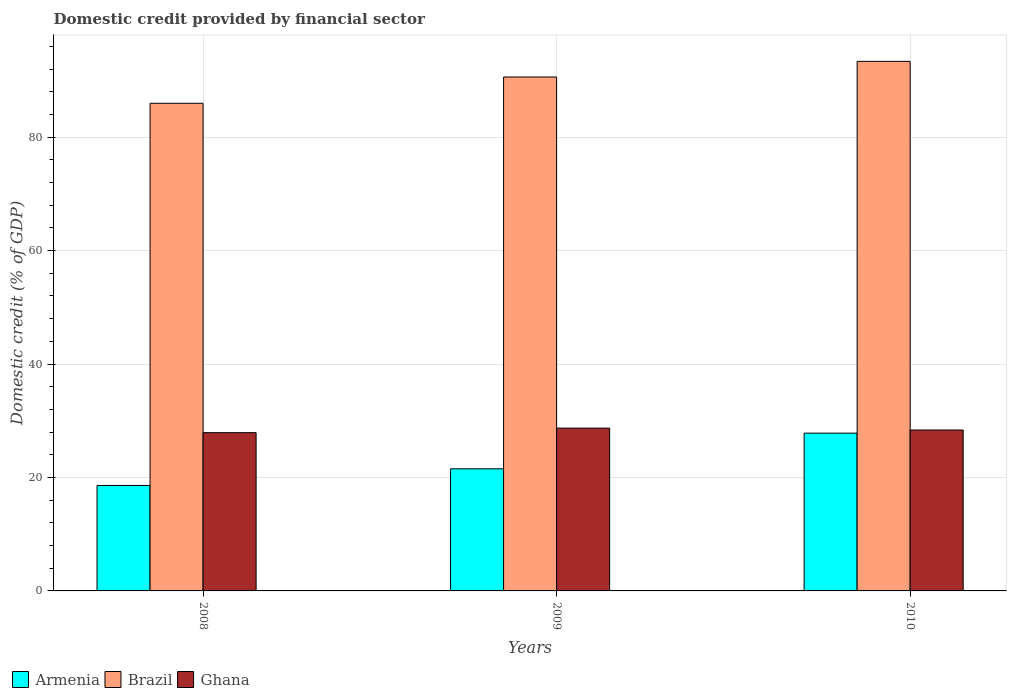How many groups of bars are there?
Provide a succinct answer. 3. Are the number of bars per tick equal to the number of legend labels?
Ensure brevity in your answer.  Yes. Are the number of bars on each tick of the X-axis equal?
Your answer should be compact. Yes. How many bars are there on the 2nd tick from the right?
Offer a very short reply. 3. What is the label of the 2nd group of bars from the left?
Give a very brief answer. 2009. In how many cases, is the number of bars for a given year not equal to the number of legend labels?
Offer a terse response. 0. What is the domestic credit in Ghana in 2010?
Your answer should be very brief. 28.37. Across all years, what is the maximum domestic credit in Armenia?
Provide a short and direct response. 27.82. Across all years, what is the minimum domestic credit in Ghana?
Provide a short and direct response. 27.9. In which year was the domestic credit in Ghana minimum?
Offer a terse response. 2008. What is the total domestic credit in Brazil in the graph?
Your response must be concise. 269.94. What is the difference between the domestic credit in Armenia in 2008 and that in 2009?
Make the answer very short. -2.94. What is the difference between the domestic credit in Brazil in 2008 and the domestic credit in Ghana in 2010?
Keep it short and to the point. 57.6. What is the average domestic credit in Armenia per year?
Provide a succinct answer. 22.65. In the year 2010, what is the difference between the domestic credit in Brazil and domestic credit in Armenia?
Make the answer very short. 65.55. In how many years, is the domestic credit in Brazil greater than 56 %?
Give a very brief answer. 3. What is the ratio of the domestic credit in Ghana in 2008 to that in 2010?
Give a very brief answer. 0.98. Is the domestic credit in Armenia in 2008 less than that in 2010?
Your answer should be very brief. Yes. Is the difference between the domestic credit in Brazil in 2009 and 2010 greater than the difference between the domestic credit in Armenia in 2009 and 2010?
Offer a very short reply. Yes. What is the difference between the highest and the second highest domestic credit in Armenia?
Offer a very short reply. 6.29. What is the difference between the highest and the lowest domestic credit in Brazil?
Ensure brevity in your answer.  7.39. Is it the case that in every year, the sum of the domestic credit in Ghana and domestic credit in Brazil is greater than the domestic credit in Armenia?
Make the answer very short. Yes. How many bars are there?
Provide a short and direct response. 9. How many years are there in the graph?
Offer a very short reply. 3. Are the values on the major ticks of Y-axis written in scientific E-notation?
Your answer should be compact. No. Does the graph contain any zero values?
Give a very brief answer. No. Does the graph contain grids?
Provide a succinct answer. Yes. How many legend labels are there?
Give a very brief answer. 3. What is the title of the graph?
Provide a succinct answer. Domestic credit provided by financial sector. Does "Grenada" appear as one of the legend labels in the graph?
Offer a terse response. No. What is the label or title of the Y-axis?
Make the answer very short. Domestic credit (% of GDP). What is the Domestic credit (% of GDP) of Armenia in 2008?
Your answer should be compact. 18.59. What is the Domestic credit (% of GDP) in Brazil in 2008?
Make the answer very short. 85.97. What is the Domestic credit (% of GDP) in Ghana in 2008?
Ensure brevity in your answer.  27.9. What is the Domestic credit (% of GDP) in Armenia in 2009?
Your answer should be very brief. 21.53. What is the Domestic credit (% of GDP) in Brazil in 2009?
Keep it short and to the point. 90.61. What is the Domestic credit (% of GDP) of Ghana in 2009?
Your answer should be very brief. 28.7. What is the Domestic credit (% of GDP) in Armenia in 2010?
Keep it short and to the point. 27.82. What is the Domestic credit (% of GDP) of Brazil in 2010?
Keep it short and to the point. 93.36. What is the Domestic credit (% of GDP) in Ghana in 2010?
Offer a terse response. 28.37. Across all years, what is the maximum Domestic credit (% of GDP) of Armenia?
Keep it short and to the point. 27.82. Across all years, what is the maximum Domestic credit (% of GDP) in Brazil?
Offer a very short reply. 93.36. Across all years, what is the maximum Domestic credit (% of GDP) of Ghana?
Offer a very short reply. 28.7. Across all years, what is the minimum Domestic credit (% of GDP) in Armenia?
Your answer should be very brief. 18.59. Across all years, what is the minimum Domestic credit (% of GDP) of Brazil?
Offer a very short reply. 85.97. Across all years, what is the minimum Domestic credit (% of GDP) of Ghana?
Ensure brevity in your answer.  27.9. What is the total Domestic credit (% of GDP) in Armenia in the graph?
Your response must be concise. 67.94. What is the total Domestic credit (% of GDP) in Brazil in the graph?
Ensure brevity in your answer.  269.94. What is the total Domestic credit (% of GDP) in Ghana in the graph?
Ensure brevity in your answer.  84.97. What is the difference between the Domestic credit (% of GDP) in Armenia in 2008 and that in 2009?
Give a very brief answer. -2.94. What is the difference between the Domestic credit (% of GDP) in Brazil in 2008 and that in 2009?
Your answer should be very brief. -4.64. What is the difference between the Domestic credit (% of GDP) in Ghana in 2008 and that in 2009?
Ensure brevity in your answer.  -0.8. What is the difference between the Domestic credit (% of GDP) of Armenia in 2008 and that in 2010?
Offer a very short reply. -9.22. What is the difference between the Domestic credit (% of GDP) of Brazil in 2008 and that in 2010?
Provide a short and direct response. -7.39. What is the difference between the Domestic credit (% of GDP) of Ghana in 2008 and that in 2010?
Offer a terse response. -0.47. What is the difference between the Domestic credit (% of GDP) of Armenia in 2009 and that in 2010?
Offer a very short reply. -6.29. What is the difference between the Domestic credit (% of GDP) of Brazil in 2009 and that in 2010?
Provide a short and direct response. -2.76. What is the difference between the Domestic credit (% of GDP) of Ghana in 2009 and that in 2010?
Give a very brief answer. 0.33. What is the difference between the Domestic credit (% of GDP) in Armenia in 2008 and the Domestic credit (% of GDP) in Brazil in 2009?
Your response must be concise. -72.01. What is the difference between the Domestic credit (% of GDP) of Armenia in 2008 and the Domestic credit (% of GDP) of Ghana in 2009?
Keep it short and to the point. -10.11. What is the difference between the Domestic credit (% of GDP) in Brazil in 2008 and the Domestic credit (% of GDP) in Ghana in 2009?
Ensure brevity in your answer.  57.27. What is the difference between the Domestic credit (% of GDP) in Armenia in 2008 and the Domestic credit (% of GDP) in Brazil in 2010?
Provide a succinct answer. -74.77. What is the difference between the Domestic credit (% of GDP) in Armenia in 2008 and the Domestic credit (% of GDP) in Ghana in 2010?
Offer a very short reply. -9.78. What is the difference between the Domestic credit (% of GDP) of Brazil in 2008 and the Domestic credit (% of GDP) of Ghana in 2010?
Provide a short and direct response. 57.6. What is the difference between the Domestic credit (% of GDP) in Armenia in 2009 and the Domestic credit (% of GDP) in Brazil in 2010?
Your response must be concise. -71.84. What is the difference between the Domestic credit (% of GDP) in Armenia in 2009 and the Domestic credit (% of GDP) in Ghana in 2010?
Keep it short and to the point. -6.84. What is the difference between the Domestic credit (% of GDP) of Brazil in 2009 and the Domestic credit (% of GDP) of Ghana in 2010?
Give a very brief answer. 62.24. What is the average Domestic credit (% of GDP) of Armenia per year?
Ensure brevity in your answer.  22.65. What is the average Domestic credit (% of GDP) in Brazil per year?
Provide a succinct answer. 89.98. What is the average Domestic credit (% of GDP) of Ghana per year?
Make the answer very short. 28.32. In the year 2008, what is the difference between the Domestic credit (% of GDP) of Armenia and Domestic credit (% of GDP) of Brazil?
Keep it short and to the point. -67.38. In the year 2008, what is the difference between the Domestic credit (% of GDP) of Armenia and Domestic credit (% of GDP) of Ghana?
Offer a terse response. -9.31. In the year 2008, what is the difference between the Domestic credit (% of GDP) of Brazil and Domestic credit (% of GDP) of Ghana?
Offer a very short reply. 58.07. In the year 2009, what is the difference between the Domestic credit (% of GDP) of Armenia and Domestic credit (% of GDP) of Brazil?
Your answer should be very brief. -69.08. In the year 2009, what is the difference between the Domestic credit (% of GDP) of Armenia and Domestic credit (% of GDP) of Ghana?
Offer a very short reply. -7.17. In the year 2009, what is the difference between the Domestic credit (% of GDP) in Brazil and Domestic credit (% of GDP) in Ghana?
Give a very brief answer. 61.91. In the year 2010, what is the difference between the Domestic credit (% of GDP) of Armenia and Domestic credit (% of GDP) of Brazil?
Your answer should be compact. -65.55. In the year 2010, what is the difference between the Domestic credit (% of GDP) in Armenia and Domestic credit (% of GDP) in Ghana?
Your response must be concise. -0.55. In the year 2010, what is the difference between the Domestic credit (% of GDP) of Brazil and Domestic credit (% of GDP) of Ghana?
Your answer should be compact. 64.99. What is the ratio of the Domestic credit (% of GDP) in Armenia in 2008 to that in 2009?
Your response must be concise. 0.86. What is the ratio of the Domestic credit (% of GDP) of Brazil in 2008 to that in 2009?
Ensure brevity in your answer.  0.95. What is the ratio of the Domestic credit (% of GDP) of Ghana in 2008 to that in 2009?
Provide a short and direct response. 0.97. What is the ratio of the Domestic credit (% of GDP) of Armenia in 2008 to that in 2010?
Your response must be concise. 0.67. What is the ratio of the Domestic credit (% of GDP) of Brazil in 2008 to that in 2010?
Offer a terse response. 0.92. What is the ratio of the Domestic credit (% of GDP) in Ghana in 2008 to that in 2010?
Ensure brevity in your answer.  0.98. What is the ratio of the Domestic credit (% of GDP) of Armenia in 2009 to that in 2010?
Offer a very short reply. 0.77. What is the ratio of the Domestic credit (% of GDP) in Brazil in 2009 to that in 2010?
Your answer should be very brief. 0.97. What is the ratio of the Domestic credit (% of GDP) of Ghana in 2009 to that in 2010?
Make the answer very short. 1.01. What is the difference between the highest and the second highest Domestic credit (% of GDP) in Armenia?
Provide a short and direct response. 6.29. What is the difference between the highest and the second highest Domestic credit (% of GDP) in Brazil?
Offer a terse response. 2.76. What is the difference between the highest and the second highest Domestic credit (% of GDP) of Ghana?
Make the answer very short. 0.33. What is the difference between the highest and the lowest Domestic credit (% of GDP) in Armenia?
Your answer should be very brief. 9.22. What is the difference between the highest and the lowest Domestic credit (% of GDP) in Brazil?
Offer a terse response. 7.39. What is the difference between the highest and the lowest Domestic credit (% of GDP) in Ghana?
Keep it short and to the point. 0.8. 